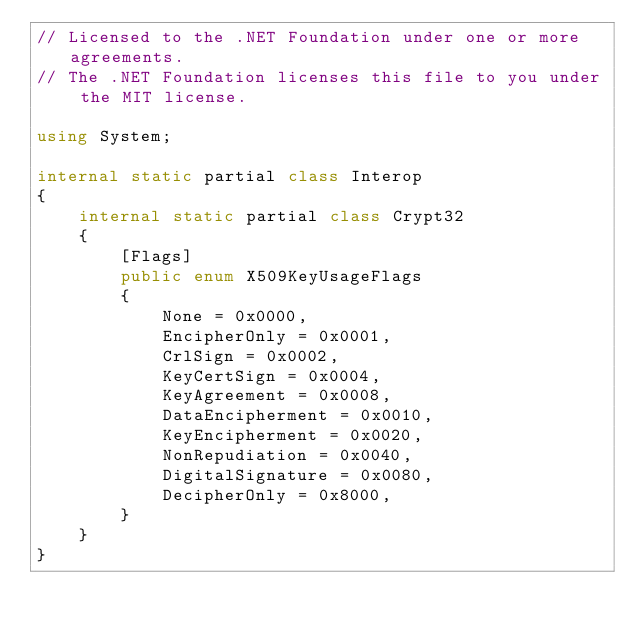<code> <loc_0><loc_0><loc_500><loc_500><_C#_>// Licensed to the .NET Foundation under one or more agreements.
// The .NET Foundation licenses this file to you under the MIT license.

using System;

internal static partial class Interop
{
    internal static partial class Crypt32
    {
        [Flags]
        public enum X509KeyUsageFlags
        {
            None = 0x0000,
            EncipherOnly = 0x0001,
            CrlSign = 0x0002,
            KeyCertSign = 0x0004,
            KeyAgreement = 0x0008,
            DataEncipherment = 0x0010,
            KeyEncipherment = 0x0020,
            NonRepudiation = 0x0040,
            DigitalSignature = 0x0080,
            DecipherOnly = 0x8000,
        }
    }
}
</code> 